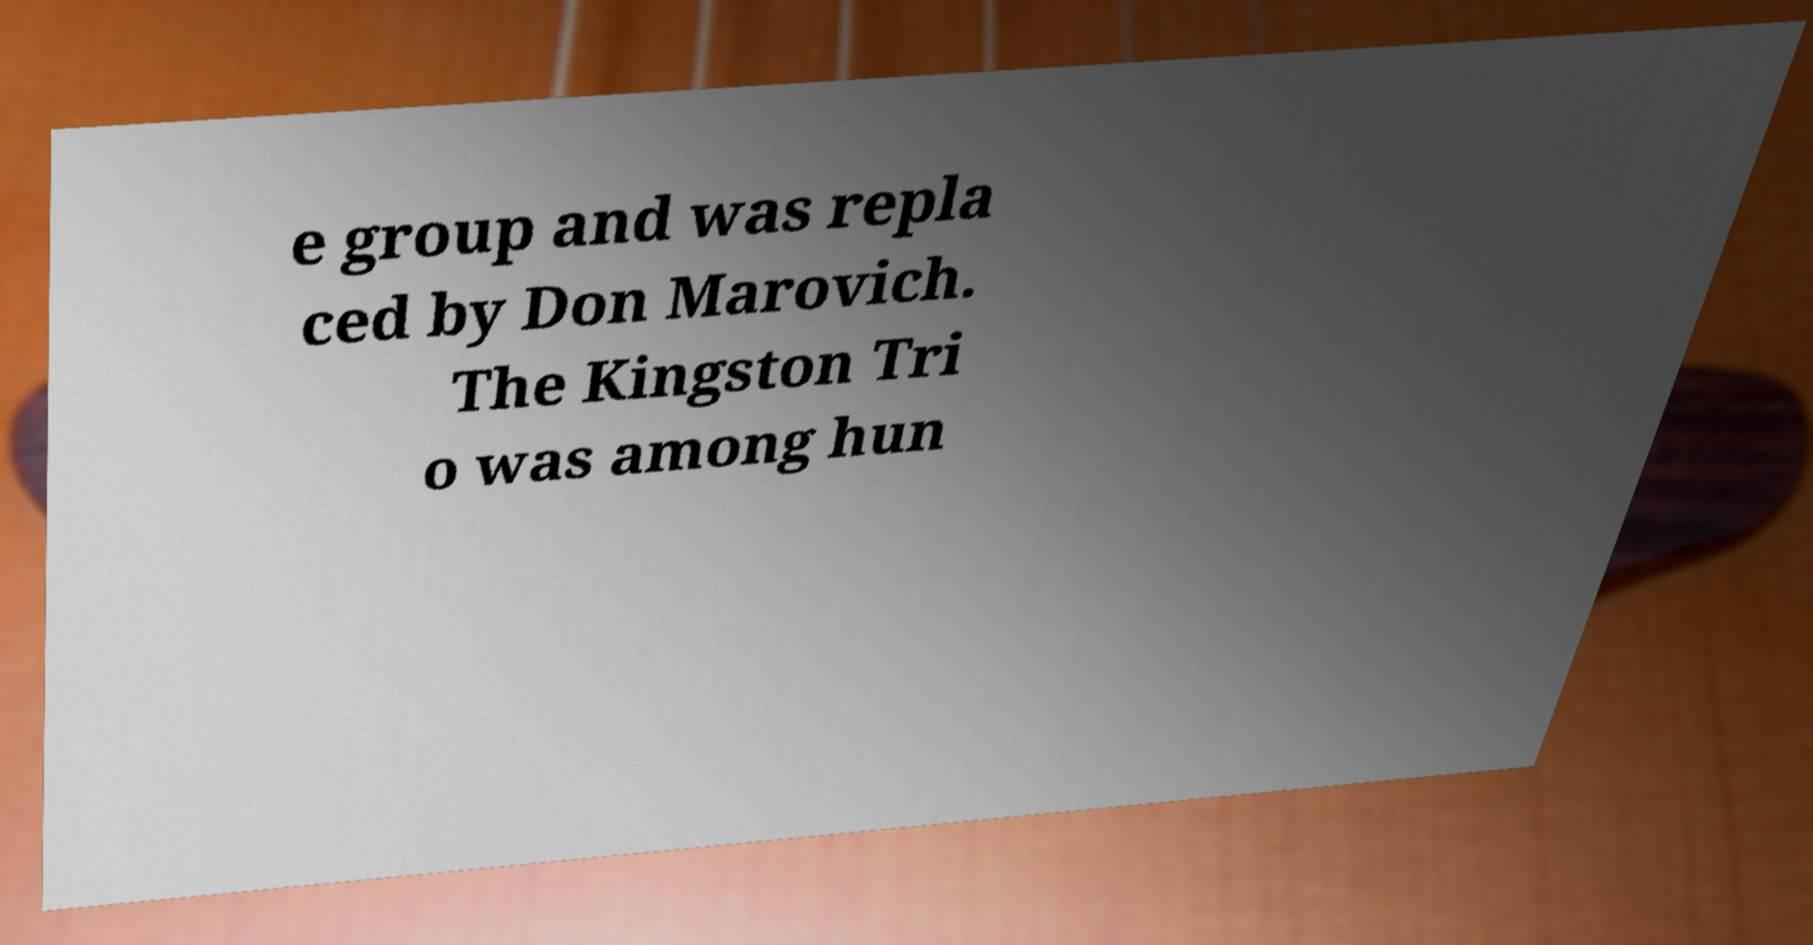Could you extract and type out the text from this image? e group and was repla ced by Don Marovich. The Kingston Tri o was among hun 